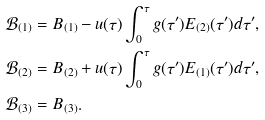Convert formula to latex. <formula><loc_0><loc_0><loc_500><loc_500>\mathcal { B } _ { ( 1 ) } & = B _ { ( 1 ) } - u ( \tau ) \int ^ { \tau } _ { 0 } g ( \tau ^ { \prime } ) E _ { ( 2 ) } ( \tau ^ { \prime } ) d \tau ^ { \prime } , \\ \mathcal { B } _ { ( 2 ) } & = B _ { ( 2 ) } + u ( \tau ) \int ^ { \tau } _ { 0 } g ( \tau ^ { \prime } ) E _ { ( 1 ) } ( \tau ^ { \prime } ) d \tau ^ { \prime } , \\ \mathcal { B } _ { ( 3 ) } & = B _ { ( 3 ) } .</formula> 